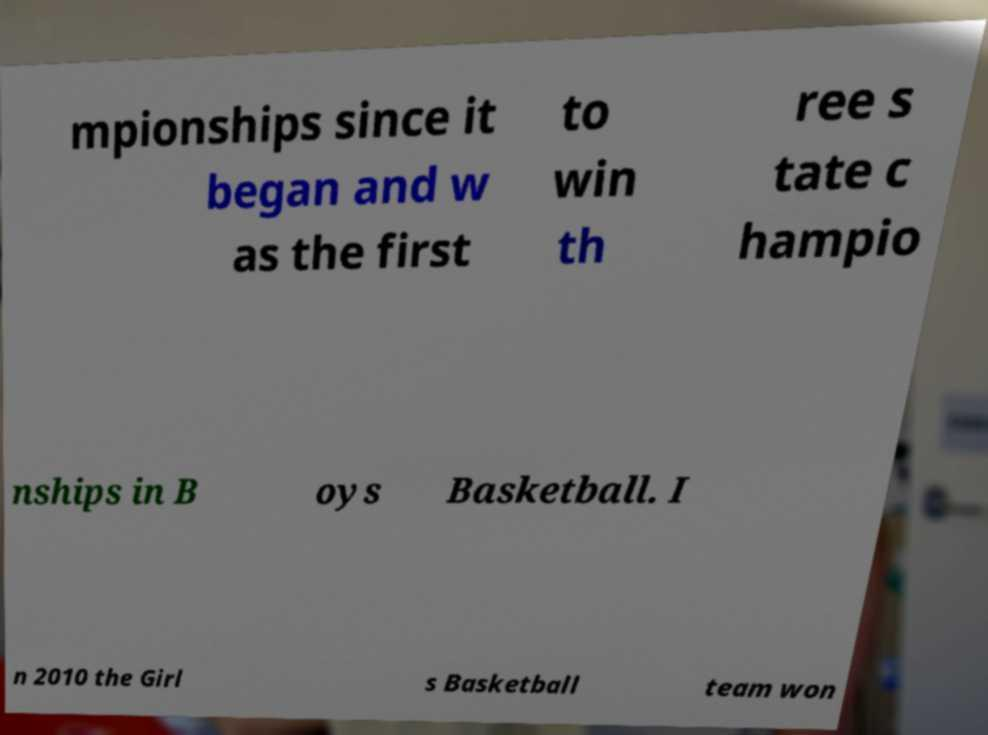There's text embedded in this image that I need extracted. Can you transcribe it verbatim? mpionships since it began and w as the first to win th ree s tate c hampio nships in B oys Basketball. I n 2010 the Girl s Basketball team won 